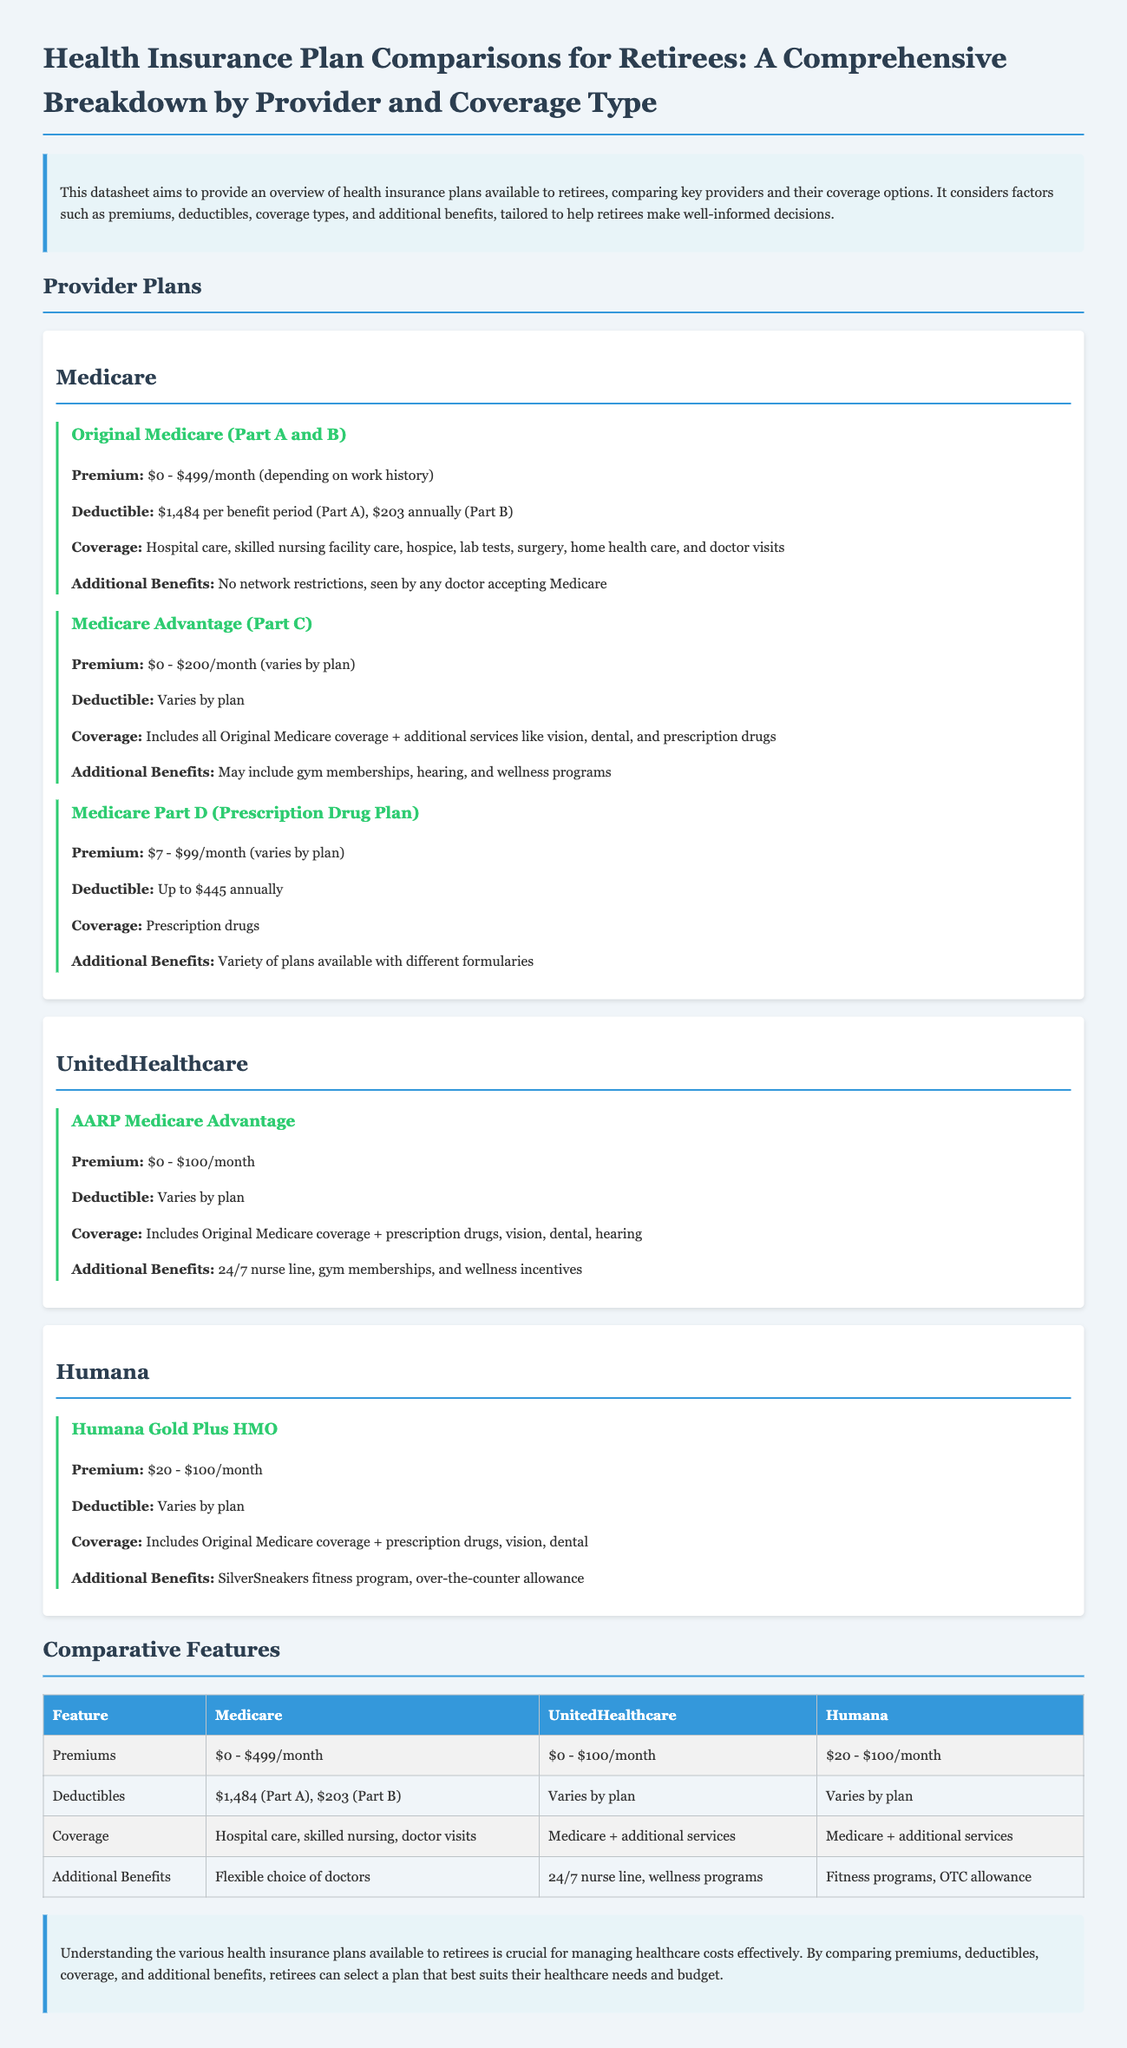What is the premium range for Original Medicare? The premium range for Original Medicare is stated in the document as $0 - $499/month, depending on work history.
Answer: $0 - $499/month What type of coverage does Medicare Advantage include? Medicare Advantage coverage includes all Original Medicare coverage plus additional services like vision, dental, and prescription drugs.
Answer: Medicare + additional services What is the deductible for Medicare Part B? The document specifies that the deductible for Medicare Part B is $203 annually.
Answer: $203 annually What additional benefit does UnitedHealthcare offer? UnitedHealthcare offers a 24/7 nurse line as an additional benefit.
Answer: 24/7 nurse line Which health insurance plan has a premium range of $20 - $100/month? The Humana Gold Plus HMO plan has a premium range stated as $20 - $100/month.
Answer: Humana Gold Plus HMO How does the deductible for Medicare compare to UnitedHealthcare and Humana? The document notes that Medicare has specific deductibles while UnitedHealthcare and Humana's deductibles vary by plan, indicating different pricing structures.
Answer: Varies by plan What is the additional benefit of the Humana plan? The Humana Gold Plus HMO plan includes the SilverSneakers fitness program as an additional benefit.
Answer: SilverSneakers fitness program What are the healthcare services covered by Medicare? The coverage includes hospital care, skilled nursing facility care, hospice, lab tests, surgery, home health care, and doctor visits.
Answer: Hospital care, skilled nursing facility care, hospice, lab tests, surgery, home health care, and doctor visits Which provider offers gym memberships? Both UnitedHealthcare and Humana provide gym memberships as part of their additional benefits.
Answer: UnitedHealthcare and Humana 